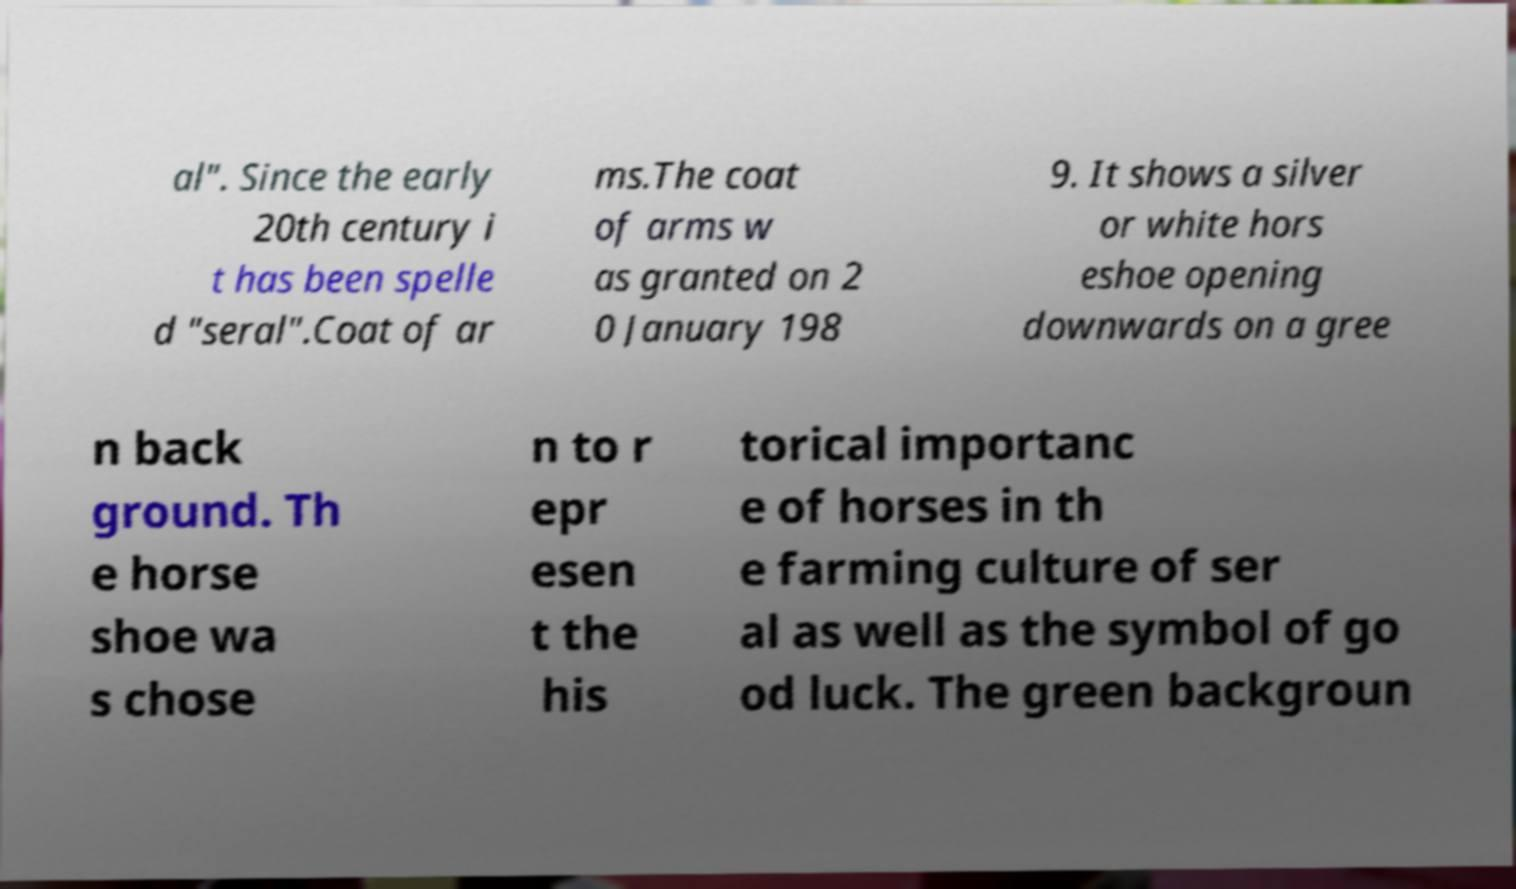Please identify and transcribe the text found in this image. al". Since the early 20th century i t has been spelle d "seral".Coat of ar ms.The coat of arms w as granted on 2 0 January 198 9. It shows a silver or white hors eshoe opening downwards on a gree n back ground. Th e horse shoe wa s chose n to r epr esen t the his torical importanc e of horses in th e farming culture of ser al as well as the symbol of go od luck. The green backgroun 